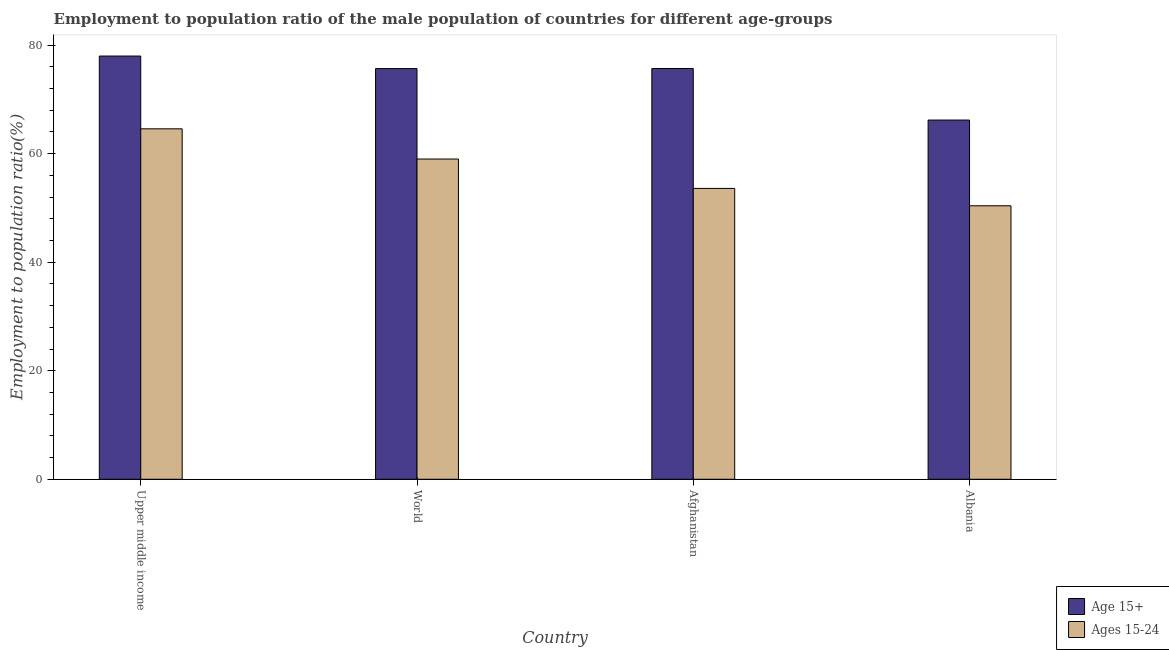How many different coloured bars are there?
Provide a succinct answer. 2. How many groups of bars are there?
Make the answer very short. 4. Are the number of bars per tick equal to the number of legend labels?
Your response must be concise. Yes. Are the number of bars on each tick of the X-axis equal?
Provide a succinct answer. Yes. How many bars are there on the 4th tick from the left?
Your answer should be very brief. 2. How many bars are there on the 2nd tick from the right?
Make the answer very short. 2. What is the label of the 2nd group of bars from the left?
Your answer should be compact. World. In how many cases, is the number of bars for a given country not equal to the number of legend labels?
Make the answer very short. 0. What is the employment to population ratio(age 15+) in Albania?
Keep it short and to the point. 66.2. Across all countries, what is the maximum employment to population ratio(age 15-24)?
Your response must be concise. 64.58. Across all countries, what is the minimum employment to population ratio(age 15-24)?
Make the answer very short. 50.4. In which country was the employment to population ratio(age 15+) maximum?
Offer a terse response. Upper middle income. In which country was the employment to population ratio(age 15+) minimum?
Offer a terse response. Albania. What is the total employment to population ratio(age 15+) in the graph?
Your answer should be compact. 295.58. What is the difference between the employment to population ratio(age 15+) in Afghanistan and that in Albania?
Offer a very short reply. 9.5. What is the difference between the employment to population ratio(age 15+) in Afghanistan and the employment to population ratio(age 15-24) in World?
Provide a succinct answer. 16.68. What is the average employment to population ratio(age 15+) per country?
Make the answer very short. 73.9. What is the difference between the employment to population ratio(age 15-24) and employment to population ratio(age 15+) in Upper middle income?
Provide a short and direct response. -13.41. What is the ratio of the employment to population ratio(age 15-24) in Afghanistan to that in Albania?
Your answer should be compact. 1.06. Is the employment to population ratio(age 15+) in Afghanistan less than that in Upper middle income?
Provide a succinct answer. Yes. What is the difference between the highest and the second highest employment to population ratio(age 15-24)?
Offer a very short reply. 5.57. What is the difference between the highest and the lowest employment to population ratio(age 15+)?
Provide a succinct answer. 11.8. What does the 1st bar from the left in Upper middle income represents?
Your answer should be very brief. Age 15+. What does the 1st bar from the right in Afghanistan represents?
Keep it short and to the point. Ages 15-24. How many bars are there?
Ensure brevity in your answer.  8. Are all the bars in the graph horizontal?
Keep it short and to the point. No. What is the difference between two consecutive major ticks on the Y-axis?
Your answer should be very brief. 20. Does the graph contain any zero values?
Provide a short and direct response. No. Where does the legend appear in the graph?
Make the answer very short. Bottom right. What is the title of the graph?
Offer a very short reply. Employment to population ratio of the male population of countries for different age-groups. What is the label or title of the X-axis?
Offer a very short reply. Country. What is the label or title of the Y-axis?
Ensure brevity in your answer.  Employment to population ratio(%). What is the Employment to population ratio(%) of Age 15+ in Upper middle income?
Provide a succinct answer. 78. What is the Employment to population ratio(%) in Ages 15-24 in Upper middle income?
Provide a succinct answer. 64.58. What is the Employment to population ratio(%) in Age 15+ in World?
Provide a succinct answer. 75.69. What is the Employment to population ratio(%) of Ages 15-24 in World?
Make the answer very short. 59.02. What is the Employment to population ratio(%) in Age 15+ in Afghanistan?
Provide a short and direct response. 75.7. What is the Employment to population ratio(%) in Ages 15-24 in Afghanistan?
Your answer should be very brief. 53.6. What is the Employment to population ratio(%) in Age 15+ in Albania?
Make the answer very short. 66.2. What is the Employment to population ratio(%) of Ages 15-24 in Albania?
Your answer should be compact. 50.4. Across all countries, what is the maximum Employment to population ratio(%) of Age 15+?
Your answer should be very brief. 78. Across all countries, what is the maximum Employment to population ratio(%) of Ages 15-24?
Your response must be concise. 64.58. Across all countries, what is the minimum Employment to population ratio(%) in Age 15+?
Keep it short and to the point. 66.2. Across all countries, what is the minimum Employment to population ratio(%) in Ages 15-24?
Make the answer very short. 50.4. What is the total Employment to population ratio(%) in Age 15+ in the graph?
Keep it short and to the point. 295.58. What is the total Employment to population ratio(%) of Ages 15-24 in the graph?
Give a very brief answer. 227.6. What is the difference between the Employment to population ratio(%) of Age 15+ in Upper middle income and that in World?
Provide a succinct answer. 2.31. What is the difference between the Employment to population ratio(%) of Ages 15-24 in Upper middle income and that in World?
Ensure brevity in your answer.  5.57. What is the difference between the Employment to population ratio(%) of Age 15+ in Upper middle income and that in Afghanistan?
Make the answer very short. 2.3. What is the difference between the Employment to population ratio(%) in Ages 15-24 in Upper middle income and that in Afghanistan?
Offer a terse response. 10.98. What is the difference between the Employment to population ratio(%) of Age 15+ in Upper middle income and that in Albania?
Your response must be concise. 11.8. What is the difference between the Employment to population ratio(%) in Ages 15-24 in Upper middle income and that in Albania?
Give a very brief answer. 14.18. What is the difference between the Employment to population ratio(%) in Age 15+ in World and that in Afghanistan?
Keep it short and to the point. -0.01. What is the difference between the Employment to population ratio(%) in Ages 15-24 in World and that in Afghanistan?
Offer a terse response. 5.42. What is the difference between the Employment to population ratio(%) of Age 15+ in World and that in Albania?
Your answer should be compact. 9.49. What is the difference between the Employment to population ratio(%) in Ages 15-24 in World and that in Albania?
Your answer should be very brief. 8.62. What is the difference between the Employment to population ratio(%) of Age 15+ in Upper middle income and the Employment to population ratio(%) of Ages 15-24 in World?
Your response must be concise. 18.98. What is the difference between the Employment to population ratio(%) of Age 15+ in Upper middle income and the Employment to population ratio(%) of Ages 15-24 in Afghanistan?
Make the answer very short. 24.4. What is the difference between the Employment to population ratio(%) of Age 15+ in Upper middle income and the Employment to population ratio(%) of Ages 15-24 in Albania?
Offer a terse response. 27.6. What is the difference between the Employment to population ratio(%) in Age 15+ in World and the Employment to population ratio(%) in Ages 15-24 in Afghanistan?
Offer a very short reply. 22.09. What is the difference between the Employment to population ratio(%) in Age 15+ in World and the Employment to population ratio(%) in Ages 15-24 in Albania?
Offer a terse response. 25.29. What is the difference between the Employment to population ratio(%) in Age 15+ in Afghanistan and the Employment to population ratio(%) in Ages 15-24 in Albania?
Provide a succinct answer. 25.3. What is the average Employment to population ratio(%) of Age 15+ per country?
Give a very brief answer. 73.9. What is the average Employment to population ratio(%) in Ages 15-24 per country?
Your answer should be very brief. 56.9. What is the difference between the Employment to population ratio(%) of Age 15+ and Employment to population ratio(%) of Ages 15-24 in Upper middle income?
Make the answer very short. 13.41. What is the difference between the Employment to population ratio(%) in Age 15+ and Employment to population ratio(%) in Ages 15-24 in World?
Your answer should be very brief. 16.67. What is the difference between the Employment to population ratio(%) of Age 15+ and Employment to population ratio(%) of Ages 15-24 in Afghanistan?
Your answer should be compact. 22.1. What is the difference between the Employment to population ratio(%) of Age 15+ and Employment to population ratio(%) of Ages 15-24 in Albania?
Provide a short and direct response. 15.8. What is the ratio of the Employment to population ratio(%) of Age 15+ in Upper middle income to that in World?
Keep it short and to the point. 1.03. What is the ratio of the Employment to population ratio(%) of Ages 15-24 in Upper middle income to that in World?
Make the answer very short. 1.09. What is the ratio of the Employment to population ratio(%) of Age 15+ in Upper middle income to that in Afghanistan?
Keep it short and to the point. 1.03. What is the ratio of the Employment to population ratio(%) of Ages 15-24 in Upper middle income to that in Afghanistan?
Offer a very short reply. 1.2. What is the ratio of the Employment to population ratio(%) in Age 15+ in Upper middle income to that in Albania?
Your answer should be compact. 1.18. What is the ratio of the Employment to population ratio(%) of Ages 15-24 in Upper middle income to that in Albania?
Give a very brief answer. 1.28. What is the ratio of the Employment to population ratio(%) of Age 15+ in World to that in Afghanistan?
Give a very brief answer. 1. What is the ratio of the Employment to population ratio(%) in Ages 15-24 in World to that in Afghanistan?
Ensure brevity in your answer.  1.1. What is the ratio of the Employment to population ratio(%) in Age 15+ in World to that in Albania?
Provide a short and direct response. 1.14. What is the ratio of the Employment to population ratio(%) of Ages 15-24 in World to that in Albania?
Your answer should be compact. 1.17. What is the ratio of the Employment to population ratio(%) in Age 15+ in Afghanistan to that in Albania?
Your answer should be very brief. 1.14. What is the ratio of the Employment to population ratio(%) of Ages 15-24 in Afghanistan to that in Albania?
Your answer should be compact. 1.06. What is the difference between the highest and the second highest Employment to population ratio(%) in Age 15+?
Your answer should be compact. 2.3. What is the difference between the highest and the second highest Employment to population ratio(%) in Ages 15-24?
Provide a short and direct response. 5.57. What is the difference between the highest and the lowest Employment to population ratio(%) in Age 15+?
Offer a terse response. 11.8. What is the difference between the highest and the lowest Employment to population ratio(%) in Ages 15-24?
Ensure brevity in your answer.  14.18. 